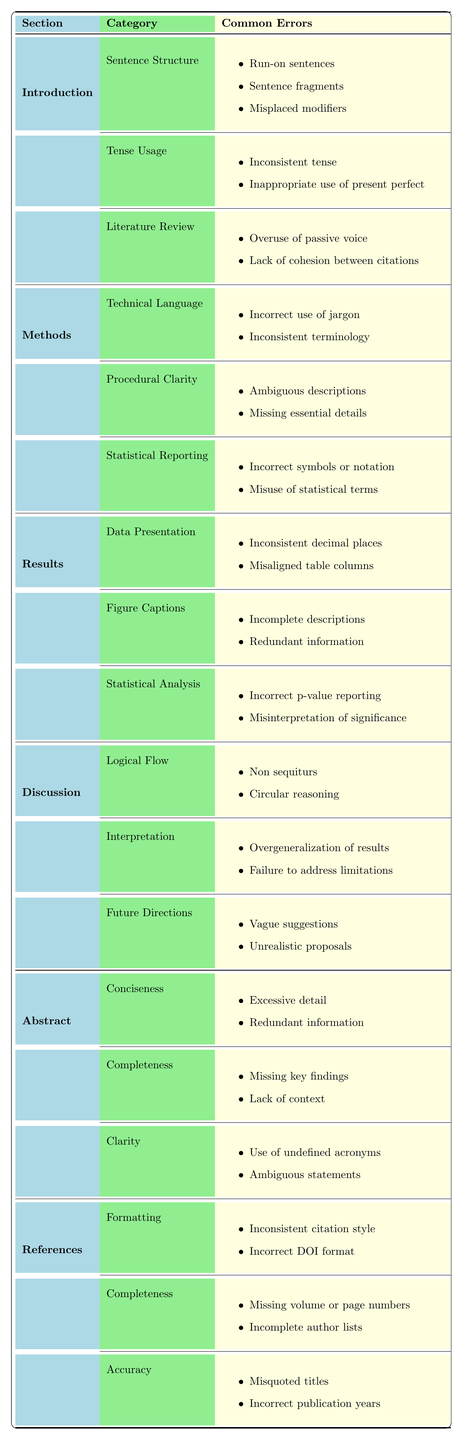What grammatical errors are commonly found in the Introduction section? The table lists common grammatical errors under the Introduction section, which include issues related to Sentence Structure, Tense Usage, and Literature Review. The specific errors under these categories are run-on sentences, sentence fragments, misplaced modifiers, inconsistent tense, inappropriate use of present perfect, overuse of passive voice, and lack of cohesion between citations.
Answer: Run-on sentences, sentence fragments, misplaced modifiers, inconsistent tense, inappropriate use of present perfect, overuse of passive voice, lack of cohesion between citations Which section of the paper has the most categories of common grammatical errors? By examining the table, the Introduction and the Methods sections both have 3 categories of common grammatical errors while others vary. Counting the categories clearly shows that these two sections are the most complex in this respect.
Answer: Introduction and Methods both have 3 categories Is "inconsistent citation style" listed as a common error? Yes, referencing the table, "inconsistent citation style" is indeed mentioned as a common error under the References section specifically in the Formatting category.
Answer: Yes How many errors are associated with the Results section? The Results section has 3 categories, each containing 2 errors. Thus, the total number of errors is 3 categories multiplied by 2 errors per category, resulting in a total of 6 errors in that section.
Answer: 6 errors What error related to Statistical Reporting is noted in the Methods section? The table indicates that errors associated with Statistical Reporting include incorrect symbols or notation and misuse of statistical terms.
Answer: Incorrect symbols or notation; misuse of statistical terms What is the most frequently mentioned type of error in the Abstract section? In the Abstract section, the most frequently mentioned type of error involves clarity-related issues with undefined acronyms and ambiguous statements noted under the Clarity category. This type of error will likely hinder comprehension, making it a focus area for editors.
Answer: Clarity-related errors Which section mentions "vague suggestions" as a common error? The section that mentions "vague suggestions" as a common error is the Discussion section, specifically under the Future Directions category. This indicates a tendency to lack specificity in proposing future research.
Answer: Discussion section If we sum the types of errors across all categories in the Introduction section, how many unique errors are identified? The Introduction section has 3 categories with a total of 7 unique errors (3 from Sentence Structure, 2 from Tense Usage, and 2 from Literature Review). Summing these gives 7 unique errors in that section.
Answer: 7 unique errors How does the overall number of errors in the Methods section compare to the Results section? The Methods section has 6 common errors spread over 3 categories, while the Results section also has 6 common errors. Therefore, the overall number of errors is equal between these two sections.
Answer: They have the same number of errors Are "incomplete descriptions" and "redundant information" both mentioned in the Results section? Yes, both "incomplete descriptions" and "redundant information" are mentioned in the Results section, specifically under the Figure Captions category, as common errors associated with how figures and tables are described.
Answer: Yes 